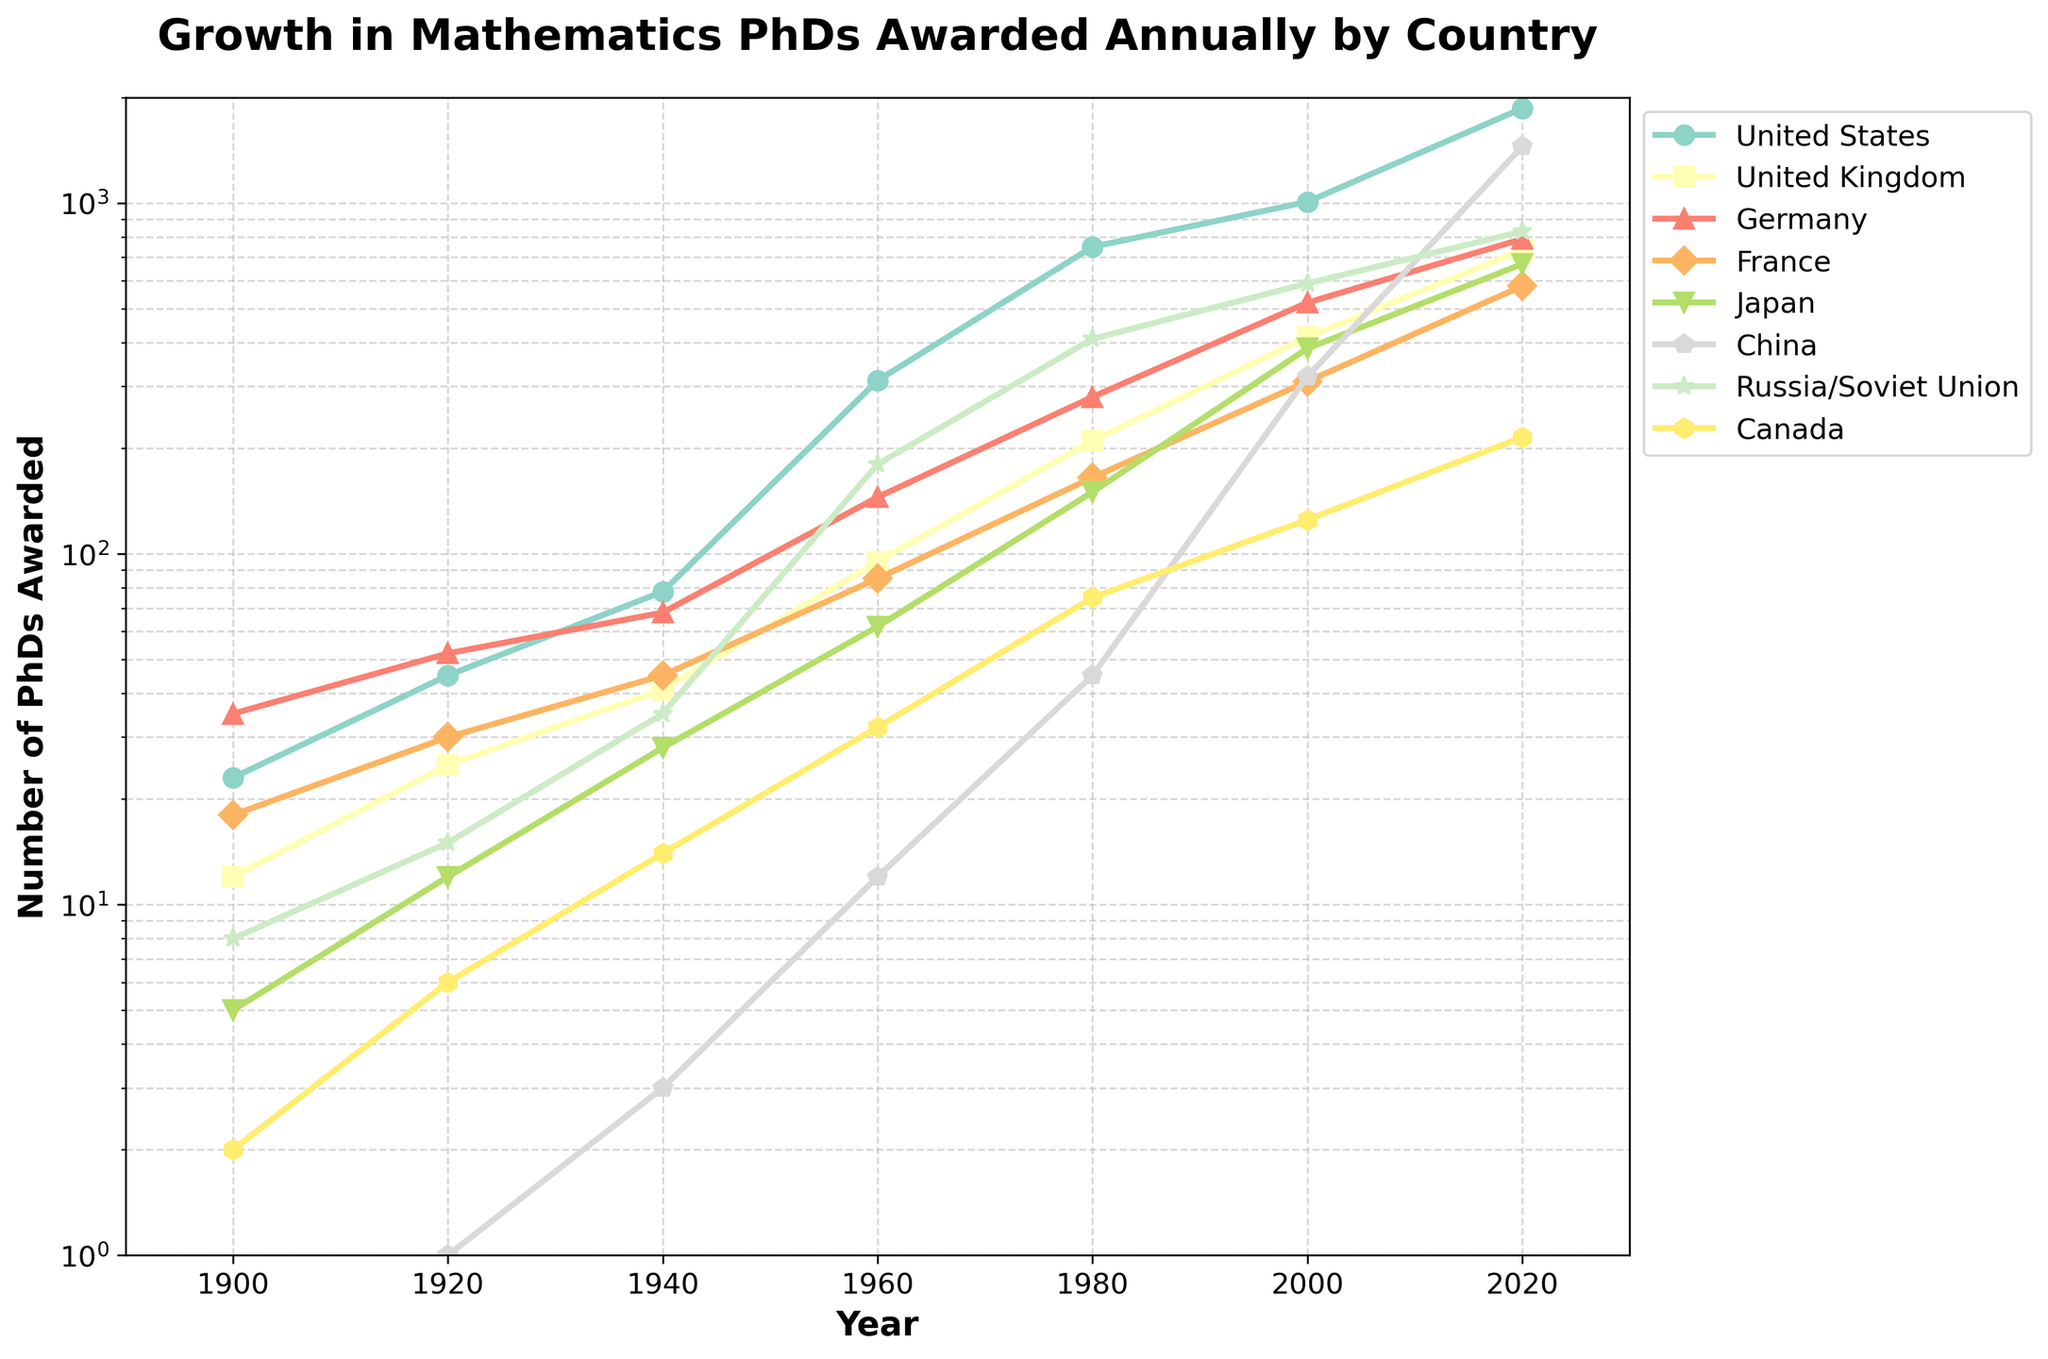Which country had the highest number of mathematics PhDs awarded in 2020? To determine the country with the highest number of mathematics PhDs awarded in 2020, we look for the tallest line segment in that year. The country corresponding to the tallest line segment in 2020 is China.
Answer: China What was the approximate increase in the number of PhDs awarded by France from 1980 to 2020? To find the increase, subtract the number of PhDs awarded in France in 1980 from the number awarded in 2020. In 1980, France awarded 165 PhDs, and in 2020, France awarded 580 PhDs. Thus, the increase is 580 - 165.
Answer: 415 Which two countries had the smallest difference in the number of PhDs awarded in 1960? To find the smallest difference, compare the number of PhDs awarded in 1960 across all pairs of countries. The smallest difference is between the United Kingdom (95) and Germany (145). Their difference is 145 - 95.
Answer: United Kingdom and Germany Calculate the average number of PhDs awarded by Japan in the years provided. To find the average, add the numbers of PhDs awarded by Japan in all the listed years, then divide by the number of years. Japan awarded 5, 12, 28, 62, 150, 385, and 670 PhDs in the given years. Sum = 5 + 12 + 28 + 62 + 150 + 385 + 670 = 1312. There are 7 years listed. The average is 1312 / 7.
Answer: 187.43 Between which two consecutive decades did the United States see the highest growth in the number of PhDs awarded? To determine this, calculate the increase in the number of PhDs awarded in each consecutive decade: 1900-1920, 1920-1940, 1940-1960, 1960-1980, 1980-2000, 2000-2020. The highest growth is between 1960 (312) and 1980 (750), where the increase is 750 - 312.
Answer: 1960 to 1980 Which country had the least growth in the number of PhDs awarded from 2000 to 2020? To find the country with the least growth, subtract the number of PhDs awarded in 2000 from the number awarded in 2020 for each country, then identify the smallest difference. For Russia/Soviet Union, the growth is 830 - 590 = 240, which is the smallest among all countries.
Answer: Russia/Soviet Union In which year did Canada see more than 100 PhDs awarded for the first time? By examining the plot, we determine the year when the line for Canada crosses the 100-PhDs mark. Canada had more than 100 PhDs awarded for the first time in the year 2000.
Answer: 2000 